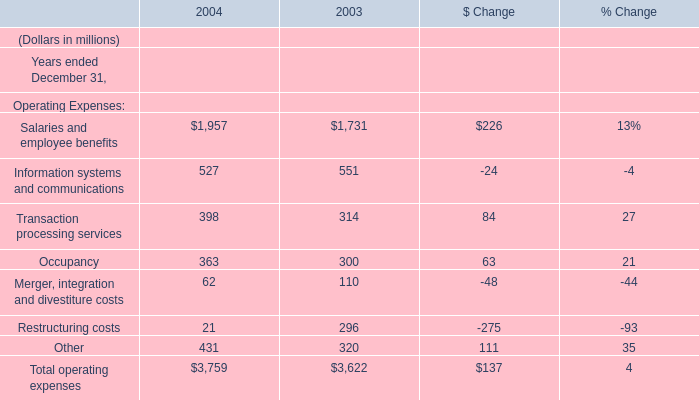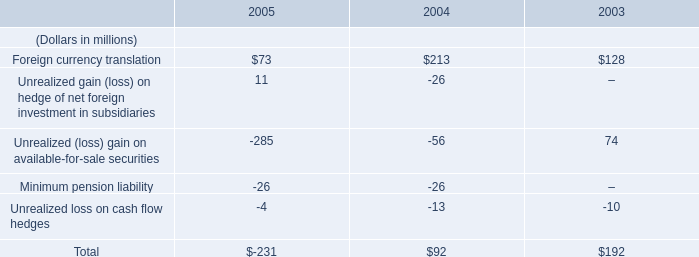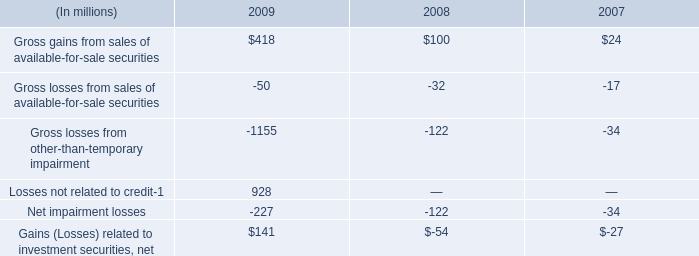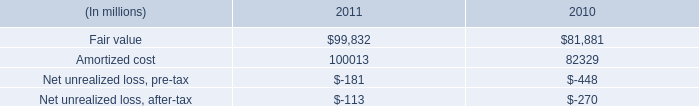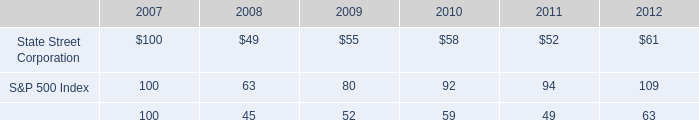what is the percent change in fair value between 2010 and 2011? 
Computations: ((99832 - 81881) / 81881)
Answer: 0.21923. 